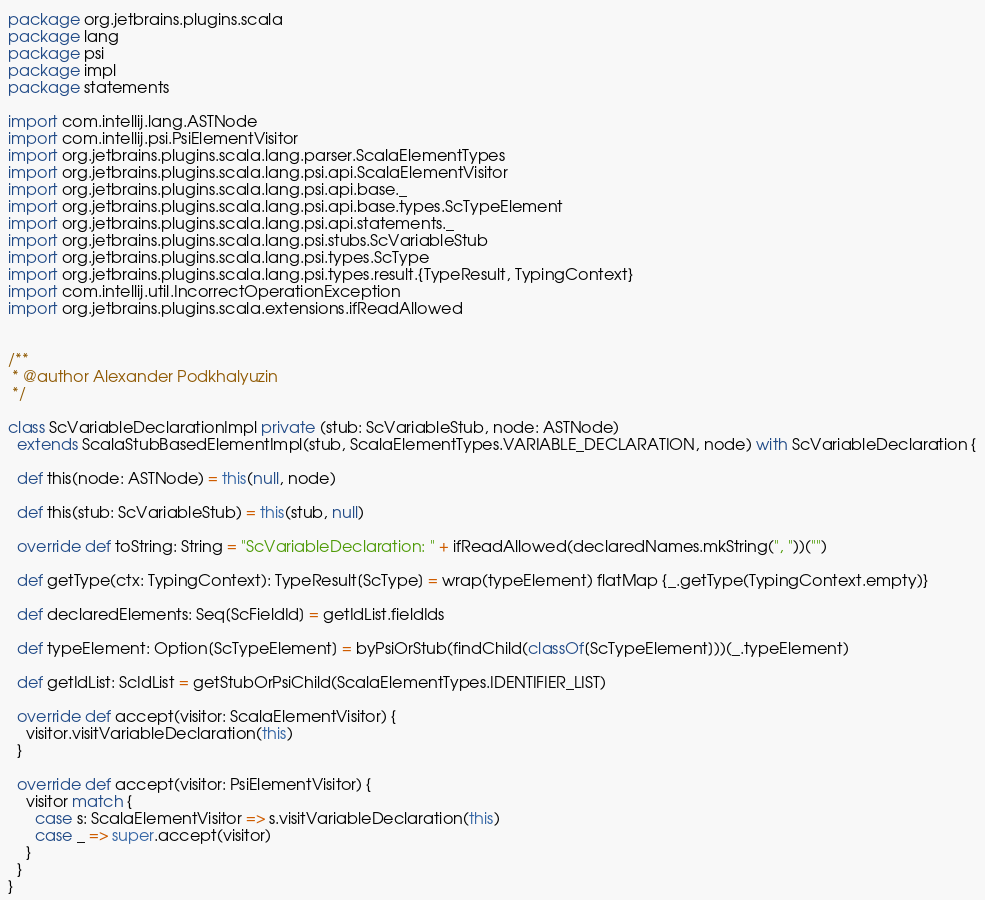Convert code to text. <code><loc_0><loc_0><loc_500><loc_500><_Scala_>package org.jetbrains.plugins.scala
package lang
package psi
package impl
package statements

import com.intellij.lang.ASTNode
import com.intellij.psi.PsiElementVisitor
import org.jetbrains.plugins.scala.lang.parser.ScalaElementTypes
import org.jetbrains.plugins.scala.lang.psi.api.ScalaElementVisitor
import org.jetbrains.plugins.scala.lang.psi.api.base._
import org.jetbrains.plugins.scala.lang.psi.api.base.types.ScTypeElement
import org.jetbrains.plugins.scala.lang.psi.api.statements._
import org.jetbrains.plugins.scala.lang.psi.stubs.ScVariableStub
import org.jetbrains.plugins.scala.lang.psi.types.ScType
import org.jetbrains.plugins.scala.lang.psi.types.result.{TypeResult, TypingContext}
import com.intellij.util.IncorrectOperationException
import org.jetbrains.plugins.scala.extensions.ifReadAllowed


/**
 * @author Alexander Podkhalyuzin
 */

class ScVariableDeclarationImpl private (stub: ScVariableStub, node: ASTNode)
  extends ScalaStubBasedElementImpl(stub, ScalaElementTypes.VARIABLE_DECLARATION, node) with ScVariableDeclaration {

  def this(node: ASTNode) = this(null, node)

  def this(stub: ScVariableStub) = this(stub, null)

  override def toString: String = "ScVariableDeclaration: " + ifReadAllowed(declaredNames.mkString(", "))("")

  def getType(ctx: TypingContext): TypeResult[ScType] = wrap(typeElement) flatMap {_.getType(TypingContext.empty)}

  def declaredElements: Seq[ScFieldId] = getIdList.fieldIds

  def typeElement: Option[ScTypeElement] = byPsiOrStub(findChild(classOf[ScTypeElement]))(_.typeElement)

  def getIdList: ScIdList = getStubOrPsiChild(ScalaElementTypes.IDENTIFIER_LIST)

  override def accept(visitor: ScalaElementVisitor) {
    visitor.visitVariableDeclaration(this)
  }

  override def accept(visitor: PsiElementVisitor) {
    visitor match {
      case s: ScalaElementVisitor => s.visitVariableDeclaration(this)
      case _ => super.accept(visitor)
    }
  }
}</code> 